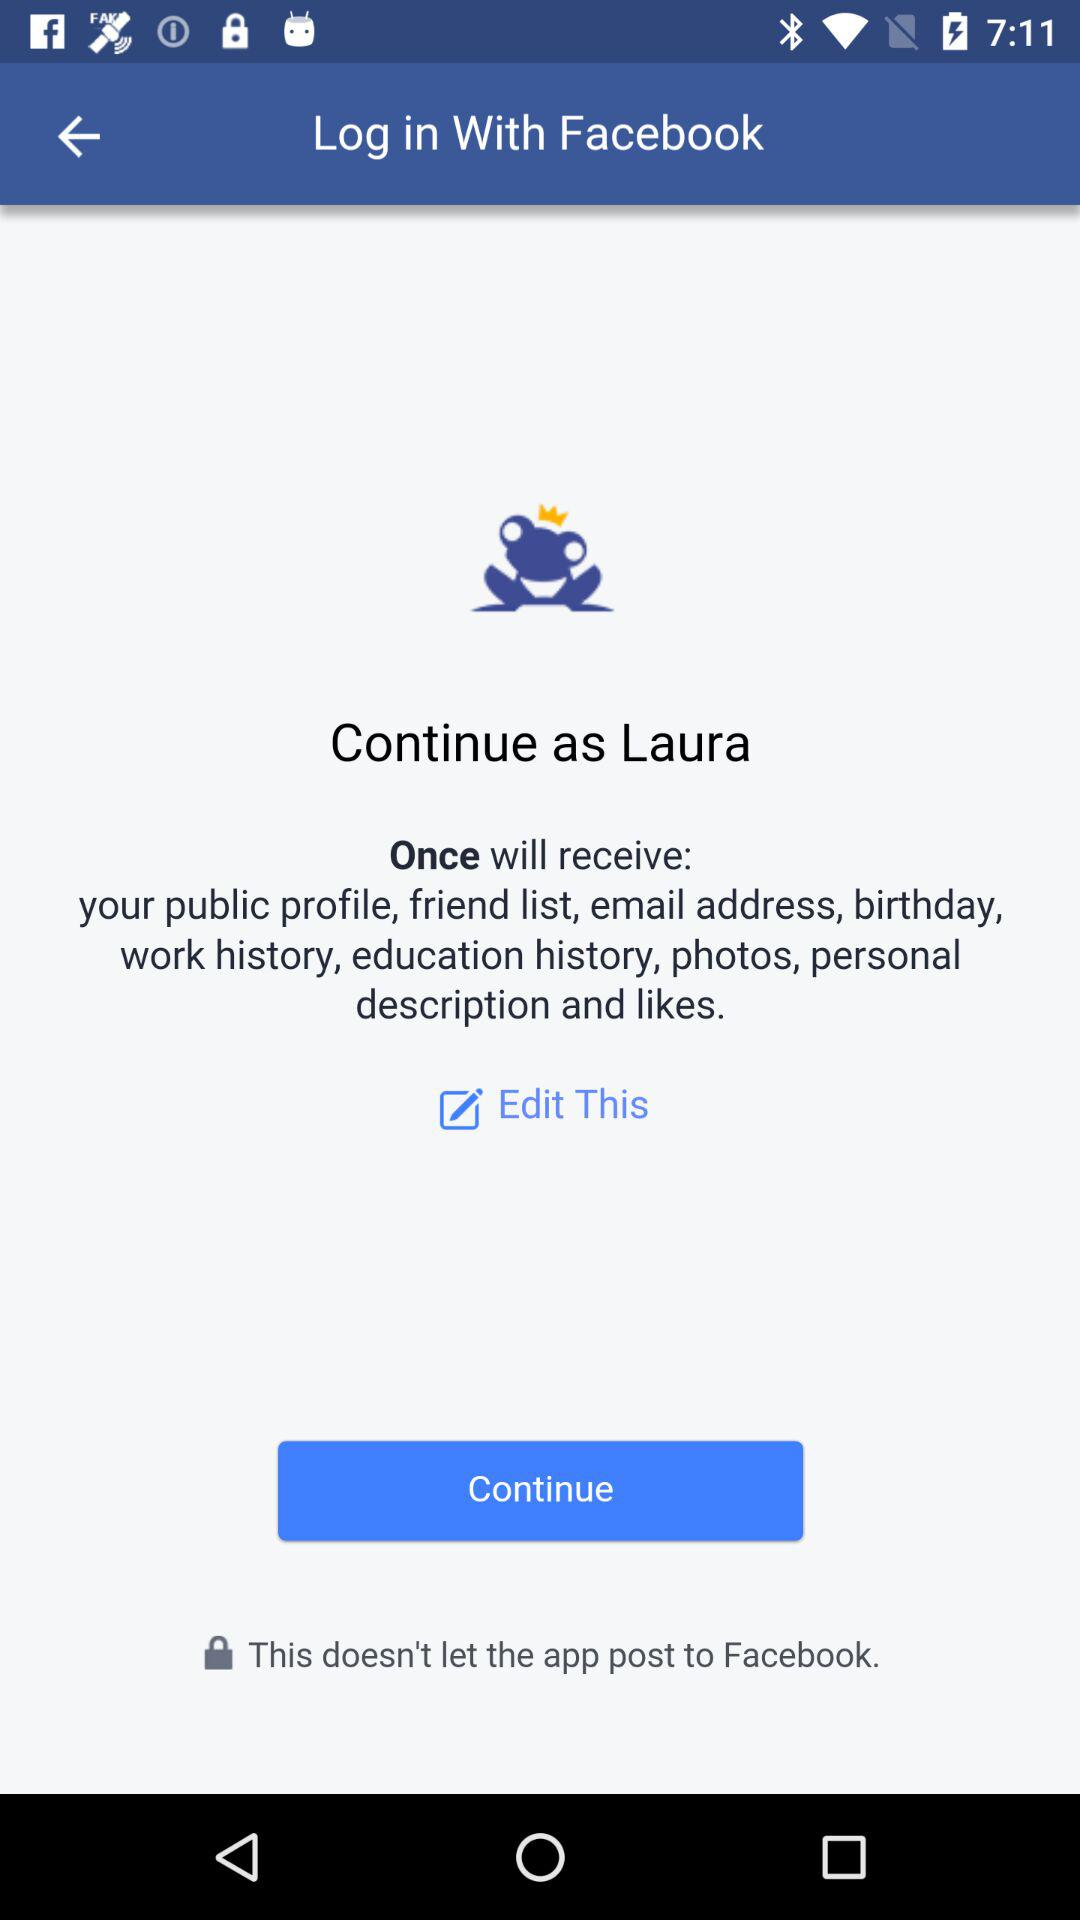What application is asking for permission? The application asking for permission is "Once". 